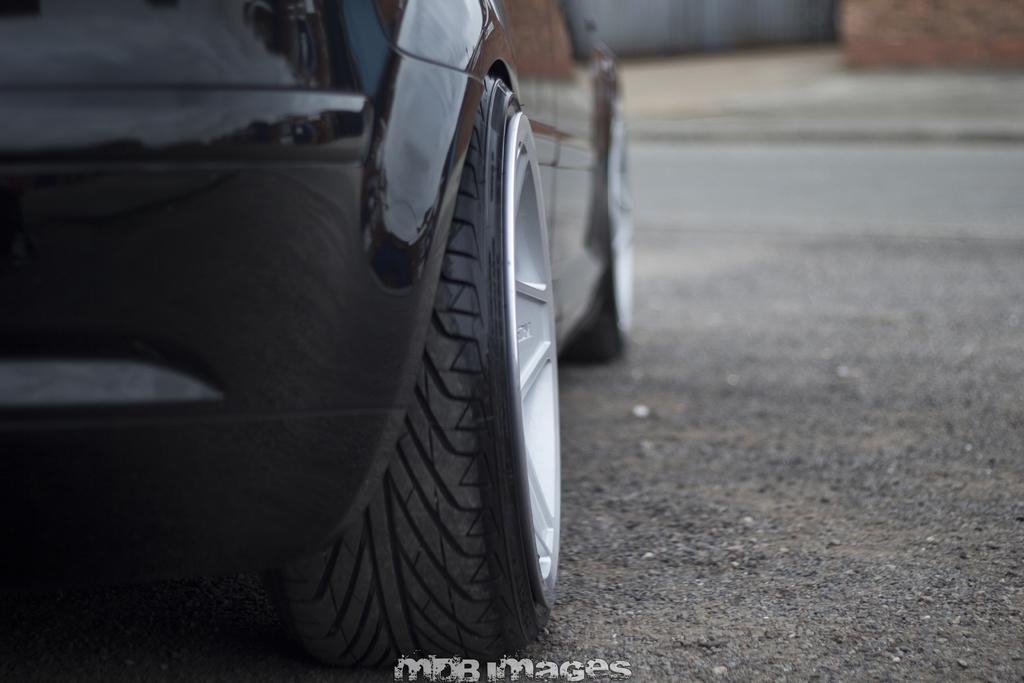Can you describe this image briefly? In this picture I can observe a car on the road. In the bottom of the picture there is a watermark. The car is in black color. The background is blurred. 